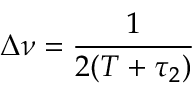<formula> <loc_0><loc_0><loc_500><loc_500>\Delta \nu = \frac { 1 } { 2 ( T + \tau _ { 2 } ) }</formula> 